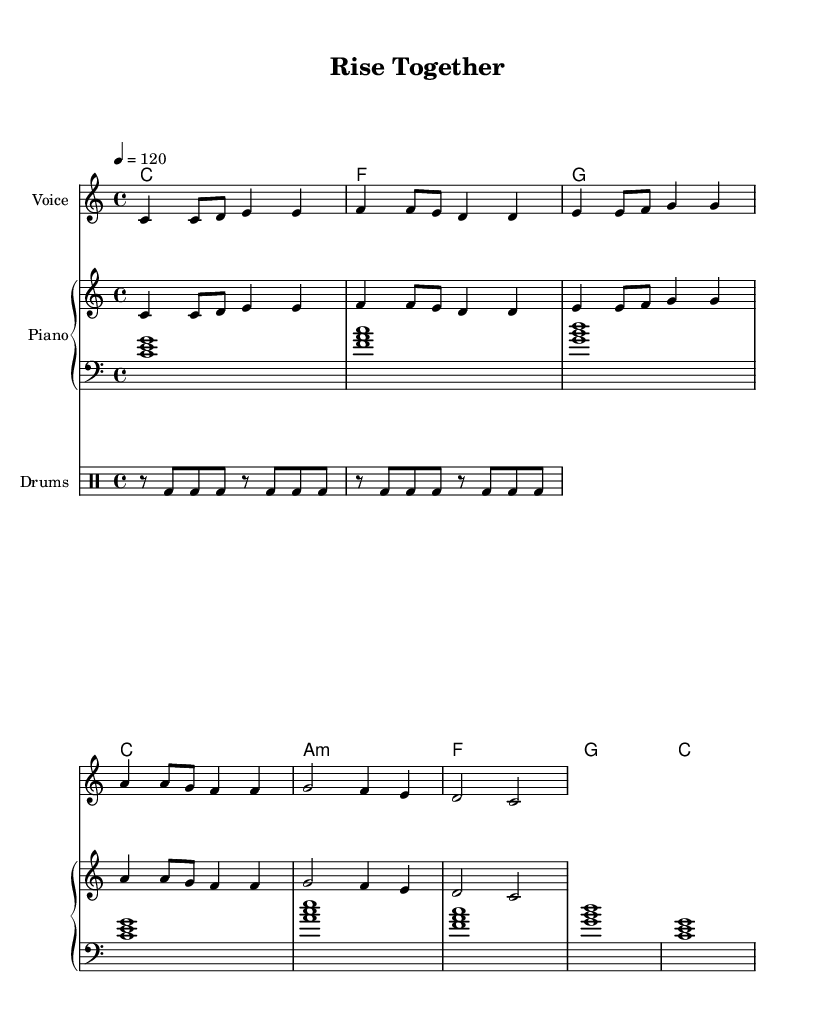What is the key signature of this music? The key signature indicated in the music is C major, which is represented by the absence of any sharps or flats in the key signature. This can be identified at the beginning of the staff where the key signature is displayed.
Answer: C major What is the time signature of this piece? The time signature displayed in the music is 4/4, which means there are four beats in each measure, and the quarter note gets one beat. This can be seen at the start of the staff typically next to the key signature.
Answer: 4/4 What is the tempo marking of this music? The tempo marking is indicated as 4 = 120, meaning that the music is to be played at a speed of 120 beats per minute. This is typically found near the beginning of the score, just under the title or header.
Answer: 120 How many measures are there in the melody? By counting the visible measures from the melody part, there are eight distinct measures in total. Measures are separated by vertical lines in the music sheet.
Answer: 8 What type of song is this based on the lyrics? The lyrics suggest a motivational theme, celebrating teamwork and professional growth, which is characteristic of a motivational pop song. This can be identified by analyzing the content and sentiment of the lyrics.
Answer: Motivational What chord is played in the first measure? The chord indicated in the first measure is C major, which is represented by the symbol "c" in the chord section of the music. Chords are generally shown above the staff lines.
Answer: C What rhythm pattern is used in the drumming part? The rhythm pattern in the drumming part consists of a repeated series of bass drum hits that occur every eighth note, specifically alternating with rests, creating a steady driving rhythm. This can be discerned by looking at the drum notation in the rhythm section.
Answer: Eighth notes 